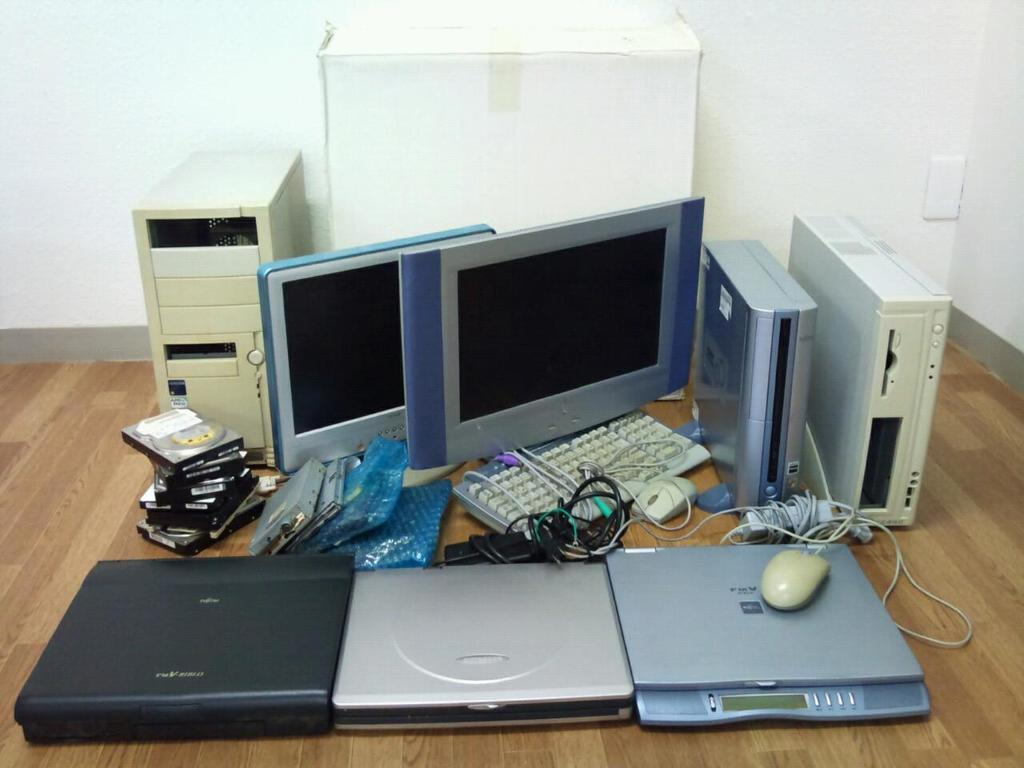What type of electronic devices are visible in the image? There are computers, DVD players, mice, monitors, and keyboards visible in the image. What are the accessories for the computers in the image? There are mice, keyboards, and wires in the image. What type of storage media is present in the image? There is a CD in the image. What is the main component of the computer system in the image? There is a CPU in the image. What additional object can be seen in the back side of the image? There is a box in the back side of the image. What type of camera is visible in the image? There is no camera present in the image. Can you tell me how many tombstones are in the cemetery in the image? There is no cemetery present in the image. 